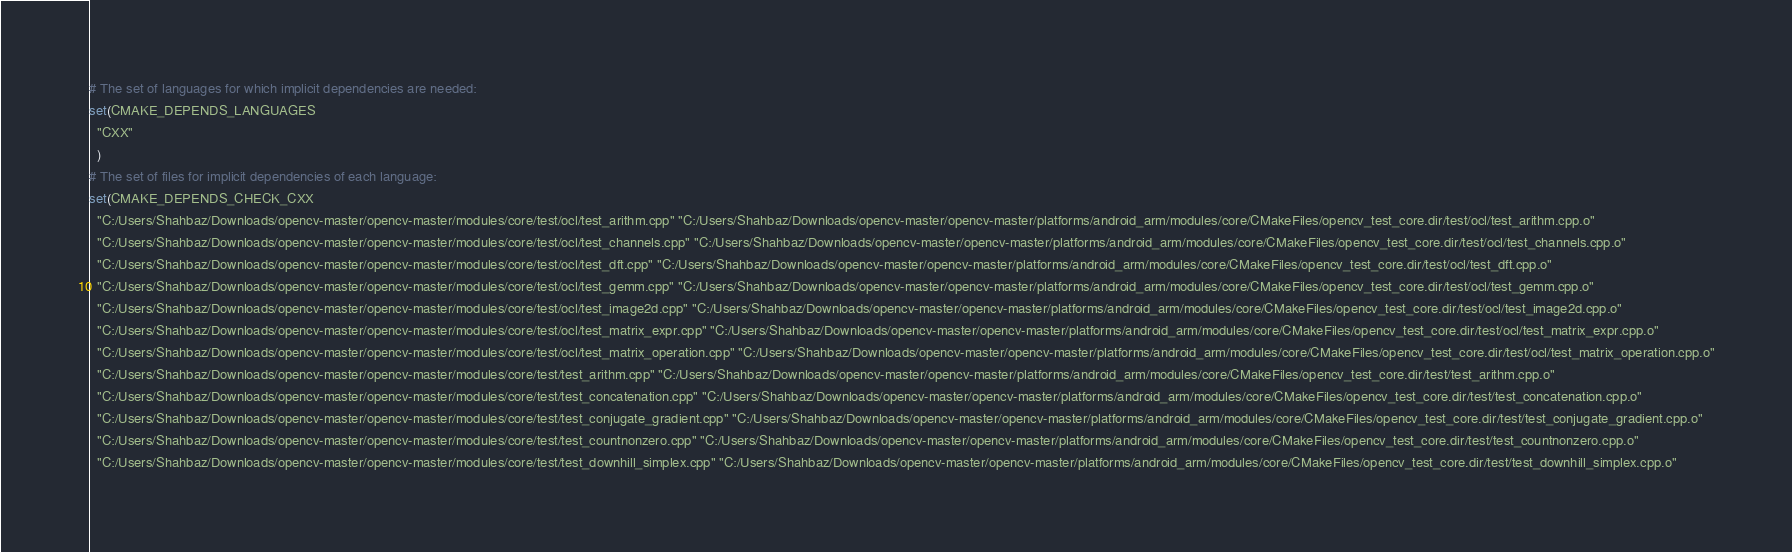Convert code to text. <code><loc_0><loc_0><loc_500><loc_500><_CMake_># The set of languages for which implicit dependencies are needed:
set(CMAKE_DEPENDS_LANGUAGES
  "CXX"
  )
# The set of files for implicit dependencies of each language:
set(CMAKE_DEPENDS_CHECK_CXX
  "C:/Users/Shahbaz/Downloads/opencv-master/opencv-master/modules/core/test/ocl/test_arithm.cpp" "C:/Users/Shahbaz/Downloads/opencv-master/opencv-master/platforms/android_arm/modules/core/CMakeFiles/opencv_test_core.dir/test/ocl/test_arithm.cpp.o"
  "C:/Users/Shahbaz/Downloads/opencv-master/opencv-master/modules/core/test/ocl/test_channels.cpp" "C:/Users/Shahbaz/Downloads/opencv-master/opencv-master/platforms/android_arm/modules/core/CMakeFiles/opencv_test_core.dir/test/ocl/test_channels.cpp.o"
  "C:/Users/Shahbaz/Downloads/opencv-master/opencv-master/modules/core/test/ocl/test_dft.cpp" "C:/Users/Shahbaz/Downloads/opencv-master/opencv-master/platforms/android_arm/modules/core/CMakeFiles/opencv_test_core.dir/test/ocl/test_dft.cpp.o"
  "C:/Users/Shahbaz/Downloads/opencv-master/opencv-master/modules/core/test/ocl/test_gemm.cpp" "C:/Users/Shahbaz/Downloads/opencv-master/opencv-master/platforms/android_arm/modules/core/CMakeFiles/opencv_test_core.dir/test/ocl/test_gemm.cpp.o"
  "C:/Users/Shahbaz/Downloads/opencv-master/opencv-master/modules/core/test/ocl/test_image2d.cpp" "C:/Users/Shahbaz/Downloads/opencv-master/opencv-master/platforms/android_arm/modules/core/CMakeFiles/opencv_test_core.dir/test/ocl/test_image2d.cpp.o"
  "C:/Users/Shahbaz/Downloads/opencv-master/opencv-master/modules/core/test/ocl/test_matrix_expr.cpp" "C:/Users/Shahbaz/Downloads/opencv-master/opencv-master/platforms/android_arm/modules/core/CMakeFiles/opencv_test_core.dir/test/ocl/test_matrix_expr.cpp.o"
  "C:/Users/Shahbaz/Downloads/opencv-master/opencv-master/modules/core/test/ocl/test_matrix_operation.cpp" "C:/Users/Shahbaz/Downloads/opencv-master/opencv-master/platforms/android_arm/modules/core/CMakeFiles/opencv_test_core.dir/test/ocl/test_matrix_operation.cpp.o"
  "C:/Users/Shahbaz/Downloads/opencv-master/opencv-master/modules/core/test/test_arithm.cpp" "C:/Users/Shahbaz/Downloads/opencv-master/opencv-master/platforms/android_arm/modules/core/CMakeFiles/opencv_test_core.dir/test/test_arithm.cpp.o"
  "C:/Users/Shahbaz/Downloads/opencv-master/opencv-master/modules/core/test/test_concatenation.cpp" "C:/Users/Shahbaz/Downloads/opencv-master/opencv-master/platforms/android_arm/modules/core/CMakeFiles/opencv_test_core.dir/test/test_concatenation.cpp.o"
  "C:/Users/Shahbaz/Downloads/opencv-master/opencv-master/modules/core/test/test_conjugate_gradient.cpp" "C:/Users/Shahbaz/Downloads/opencv-master/opencv-master/platforms/android_arm/modules/core/CMakeFiles/opencv_test_core.dir/test/test_conjugate_gradient.cpp.o"
  "C:/Users/Shahbaz/Downloads/opencv-master/opencv-master/modules/core/test/test_countnonzero.cpp" "C:/Users/Shahbaz/Downloads/opencv-master/opencv-master/platforms/android_arm/modules/core/CMakeFiles/opencv_test_core.dir/test/test_countnonzero.cpp.o"
  "C:/Users/Shahbaz/Downloads/opencv-master/opencv-master/modules/core/test/test_downhill_simplex.cpp" "C:/Users/Shahbaz/Downloads/opencv-master/opencv-master/platforms/android_arm/modules/core/CMakeFiles/opencv_test_core.dir/test/test_downhill_simplex.cpp.o"</code> 